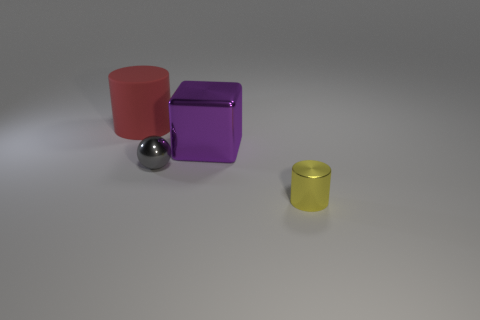Is the number of small gray metallic things that are left of the small gray metal sphere the same as the number of tiny objects that are behind the purple cube?
Keep it short and to the point. Yes. What shape is the big thing that is on the right side of the large thing on the left side of the small ball?
Offer a very short reply. Cube. Is there a tiny gray metal thing of the same shape as the big rubber thing?
Keep it short and to the point. No. What number of metal spheres are there?
Your answer should be compact. 1. Are the cylinder to the left of the purple cube and the purple cube made of the same material?
Keep it short and to the point. No. Is there a cylinder that has the same size as the metallic sphere?
Ensure brevity in your answer.  Yes. There is a tiny yellow thing; does it have the same shape as the large red rubber object that is to the left of the large purple object?
Provide a succinct answer. Yes. Are there any large metallic objects that are to the left of the large thing that is behind the big object in front of the red matte thing?
Provide a short and direct response. No. What is the size of the purple thing?
Make the answer very short. Large. What number of other things are the same color as the tiny cylinder?
Your answer should be very brief. 0. 